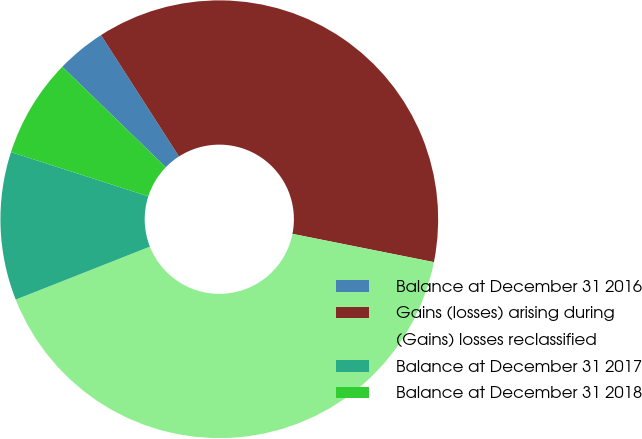Convert chart to OTSL. <chart><loc_0><loc_0><loc_500><loc_500><pie_chart><fcel>Balance at December 31 2016<fcel>Gains (losses) arising during<fcel>(Gains) losses reclassified<fcel>Balance at December 31 2017<fcel>Balance at December 31 2018<nl><fcel>3.65%<fcel>37.23%<fcel>40.88%<fcel>10.95%<fcel>7.3%<nl></chart> 